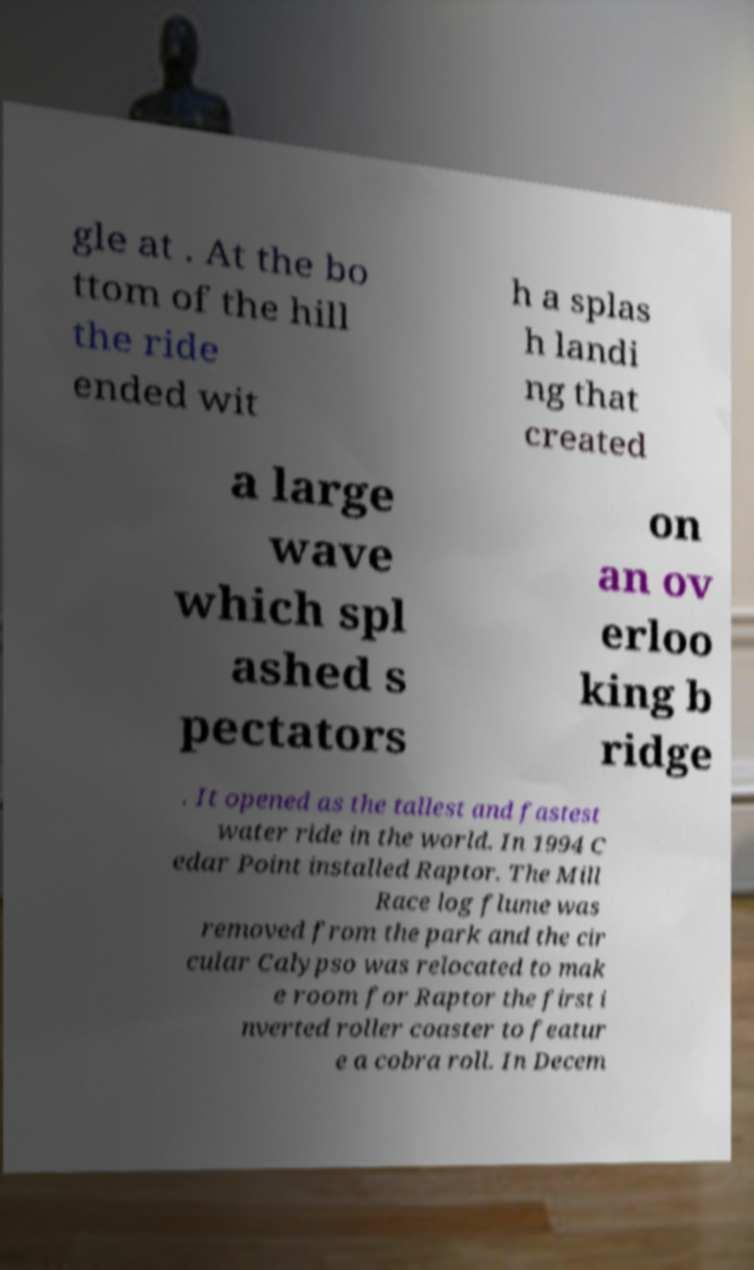Please identify and transcribe the text found in this image. gle at . At the bo ttom of the hill the ride ended wit h a splas h landi ng that created a large wave which spl ashed s pectators on an ov erloo king b ridge . It opened as the tallest and fastest water ride in the world. In 1994 C edar Point installed Raptor. The Mill Race log flume was removed from the park and the cir cular Calypso was relocated to mak e room for Raptor the first i nverted roller coaster to featur e a cobra roll. In Decem 